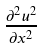<formula> <loc_0><loc_0><loc_500><loc_500>\frac { \partial ^ { 2 } u ^ { 2 } } { \partial x ^ { 2 } }</formula> 